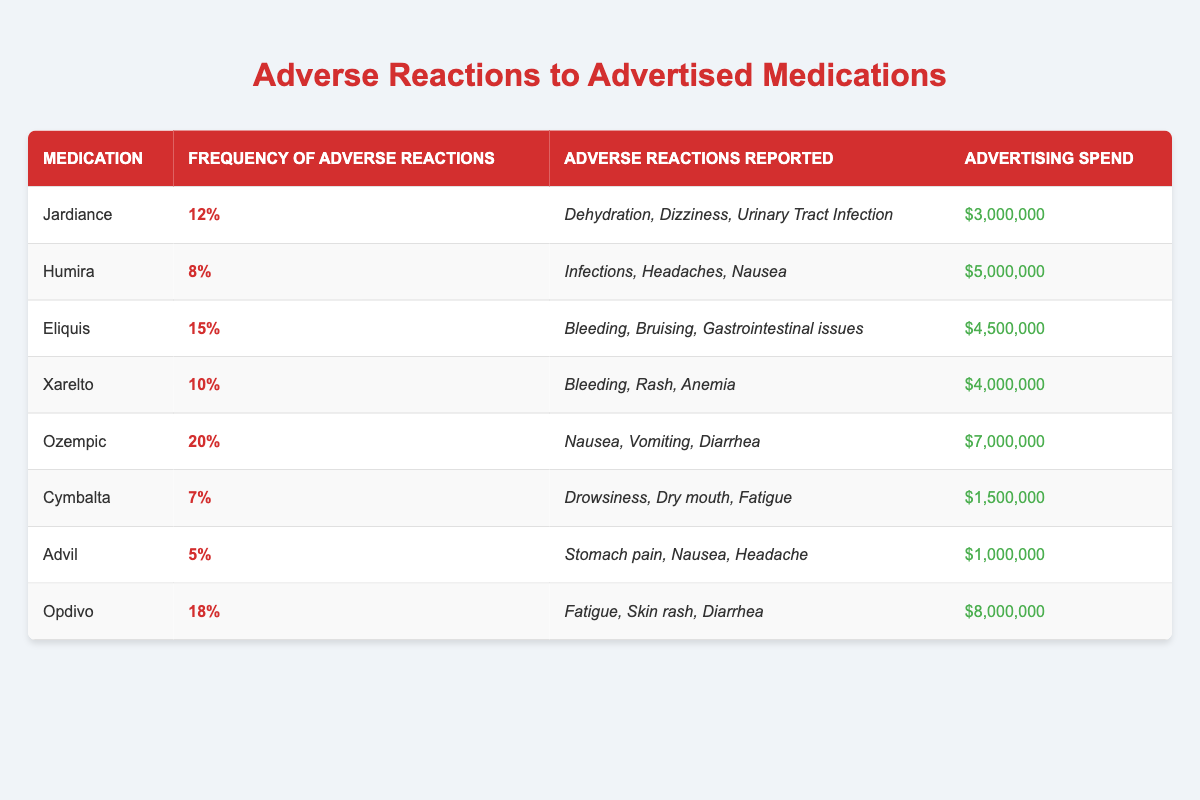What medication has the highest frequency of adverse reactions? By inspecting the frequency of adverse reactions column, Ozempic has the highest value, which is 20%.
Answer: Ozempic How many adverse reactions are reported for Eliquis? The adverse reactions reported for Eliquis are bleeding, bruising, and gastrointestinal issues, which counts to three reactions.
Answer: 3 What is the total advertising spend for all the medications in the table? The advertising spends are summed up: 3000000 + 5000000 + 4500000 + 4000000 + 7000000 + 1500000 + 1000000 + 8000000 = 30000000.
Answer: $30,000,000 Is the frequency of adverse reactions for Humira greater than for Cymbalta? Humira's frequency is 8%, while Cymbalta's is 7%. Therefore, yes, Humira has a higher frequency of adverse reactions.
Answer: Yes What is the average frequency of adverse reactions for the medications listed? To find the average, sum all frequencies (0.12 + 0.08 + 0.15 + 0.10 + 0.20 + 0.07 + 0.05 + 0.18 = 0.95) and divide by 8 (0.95 / 8 = 0.11875), which is approximately 11.88%.
Answer: 11.88% Which medication has the lowest frequency of adverse reactions? From the frequency list, Advil has the lowest frequency at 5%.
Answer: Advil What percentage of the total advertising spend do the adverse reactions for Opdivo represent? The advertising spend for Opdivo is 8000000, and the total spend is 30000000. Thus, (8000000 / 30000000) * 100 = approximately 26.67%.
Answer: 26.67% Which medication has the least number of reported adverse reactions? Cymbalta has three reported reactions (Drowsiness, Dry mouth, Fatigue) which is the least in comparison to others with more.
Answer: Cymbalta How does the frequency of adverse reactions for Xarelto compare to that of Jardiance? Xarelto has a frequency of 10%, while Jardiance has 12%. Therefore, Xarelto has a lower frequency of adverse reactions compared to Jardiance.
Answer: Lower What are the common adverse reactions reported for medications with a frequency over 15%? The medications with frequencies over 15% are Eliquis (3 reactions), Ozempic (3 reactions), and Opdivo (3 reactions), yielding: Bleeding, Bruising, Gastrointestinal issues; Nausea, Vomiting, Diarrhea; Fatigue, Skin rash, Diarrhea.
Answer: Bleeding, Bruising, Gastrointestinal issues; Nausea, Vomiting, Diarrhea; Fatigue, Skin rash, Diarrhea 